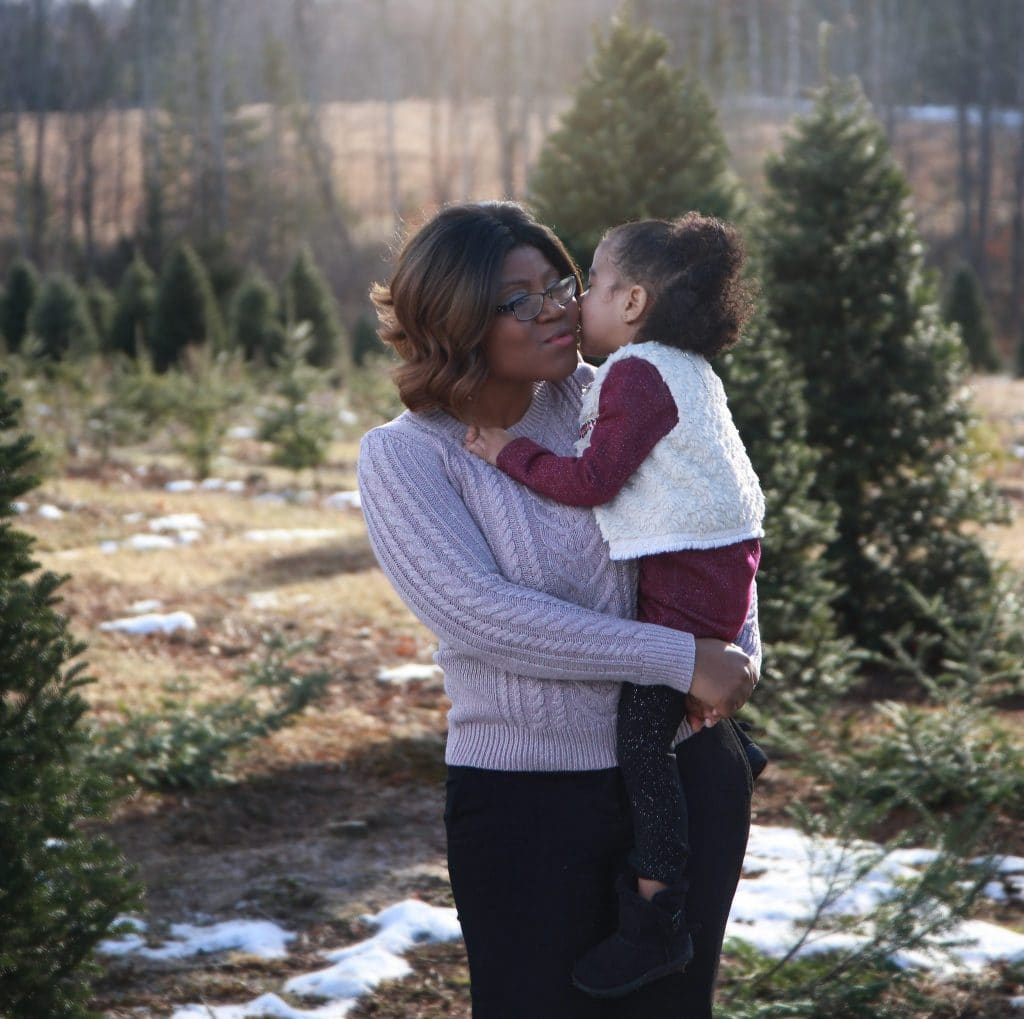What type of trees can be seen in the background, and what does this indicate about the location? The trees in the background are coniferous, likely varieties such as pines or firs, which are commonly used as Christmas trees. Given their orderly arrangement and the expansive open area visible in the image, it's indicative of a Christmas tree farm. Such farms are typical in areas with ample land and a suitable cold climate, often found in the Northern Hemisphere where there is a demand for live Christmas trees during the winter season. Additionally, the image's daylight and snowy patches suggest that it's a wintry yet sunny day, a common weather condition for tree farms during the holiday season. 